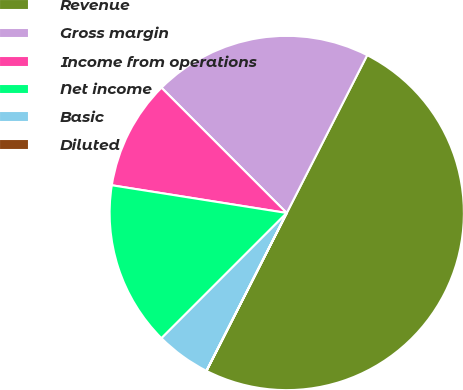Convert chart to OTSL. <chart><loc_0><loc_0><loc_500><loc_500><pie_chart><fcel>Revenue<fcel>Gross margin<fcel>Income from operations<fcel>Net income<fcel>Basic<fcel>Diluted<nl><fcel>49.98%<fcel>20.0%<fcel>10.0%<fcel>15.0%<fcel>5.01%<fcel>0.01%<nl></chart> 